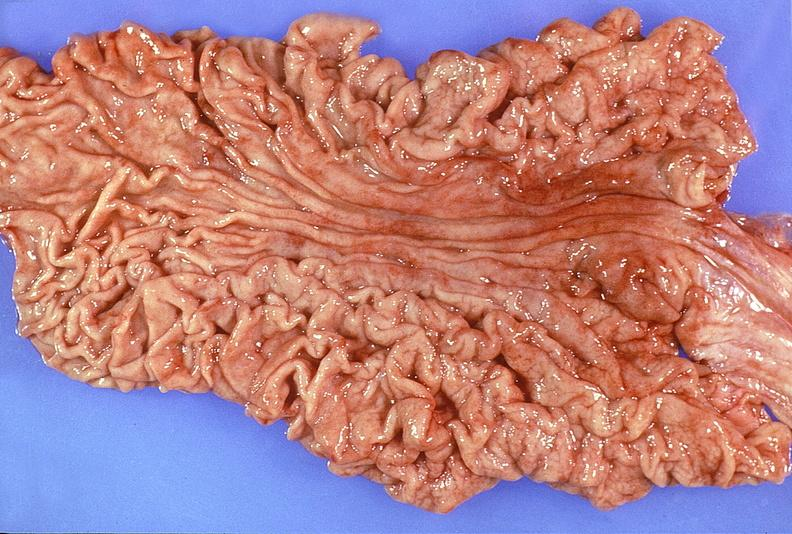does this image show normal stomach?
Answer the question using a single word or phrase. Yes 